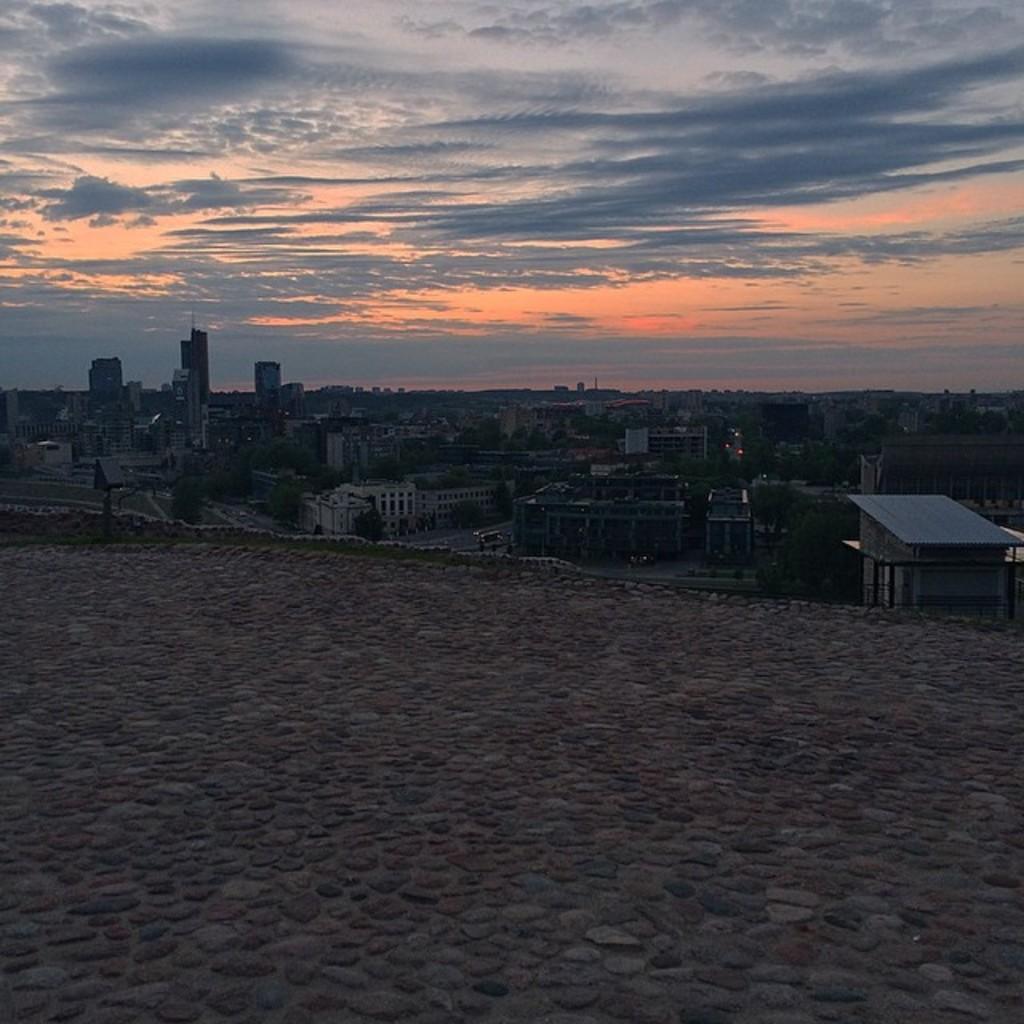How would you summarize this image in a sentence or two? In this image we can see buildings, trees, motor vehicles on the road and sky with clouds. 